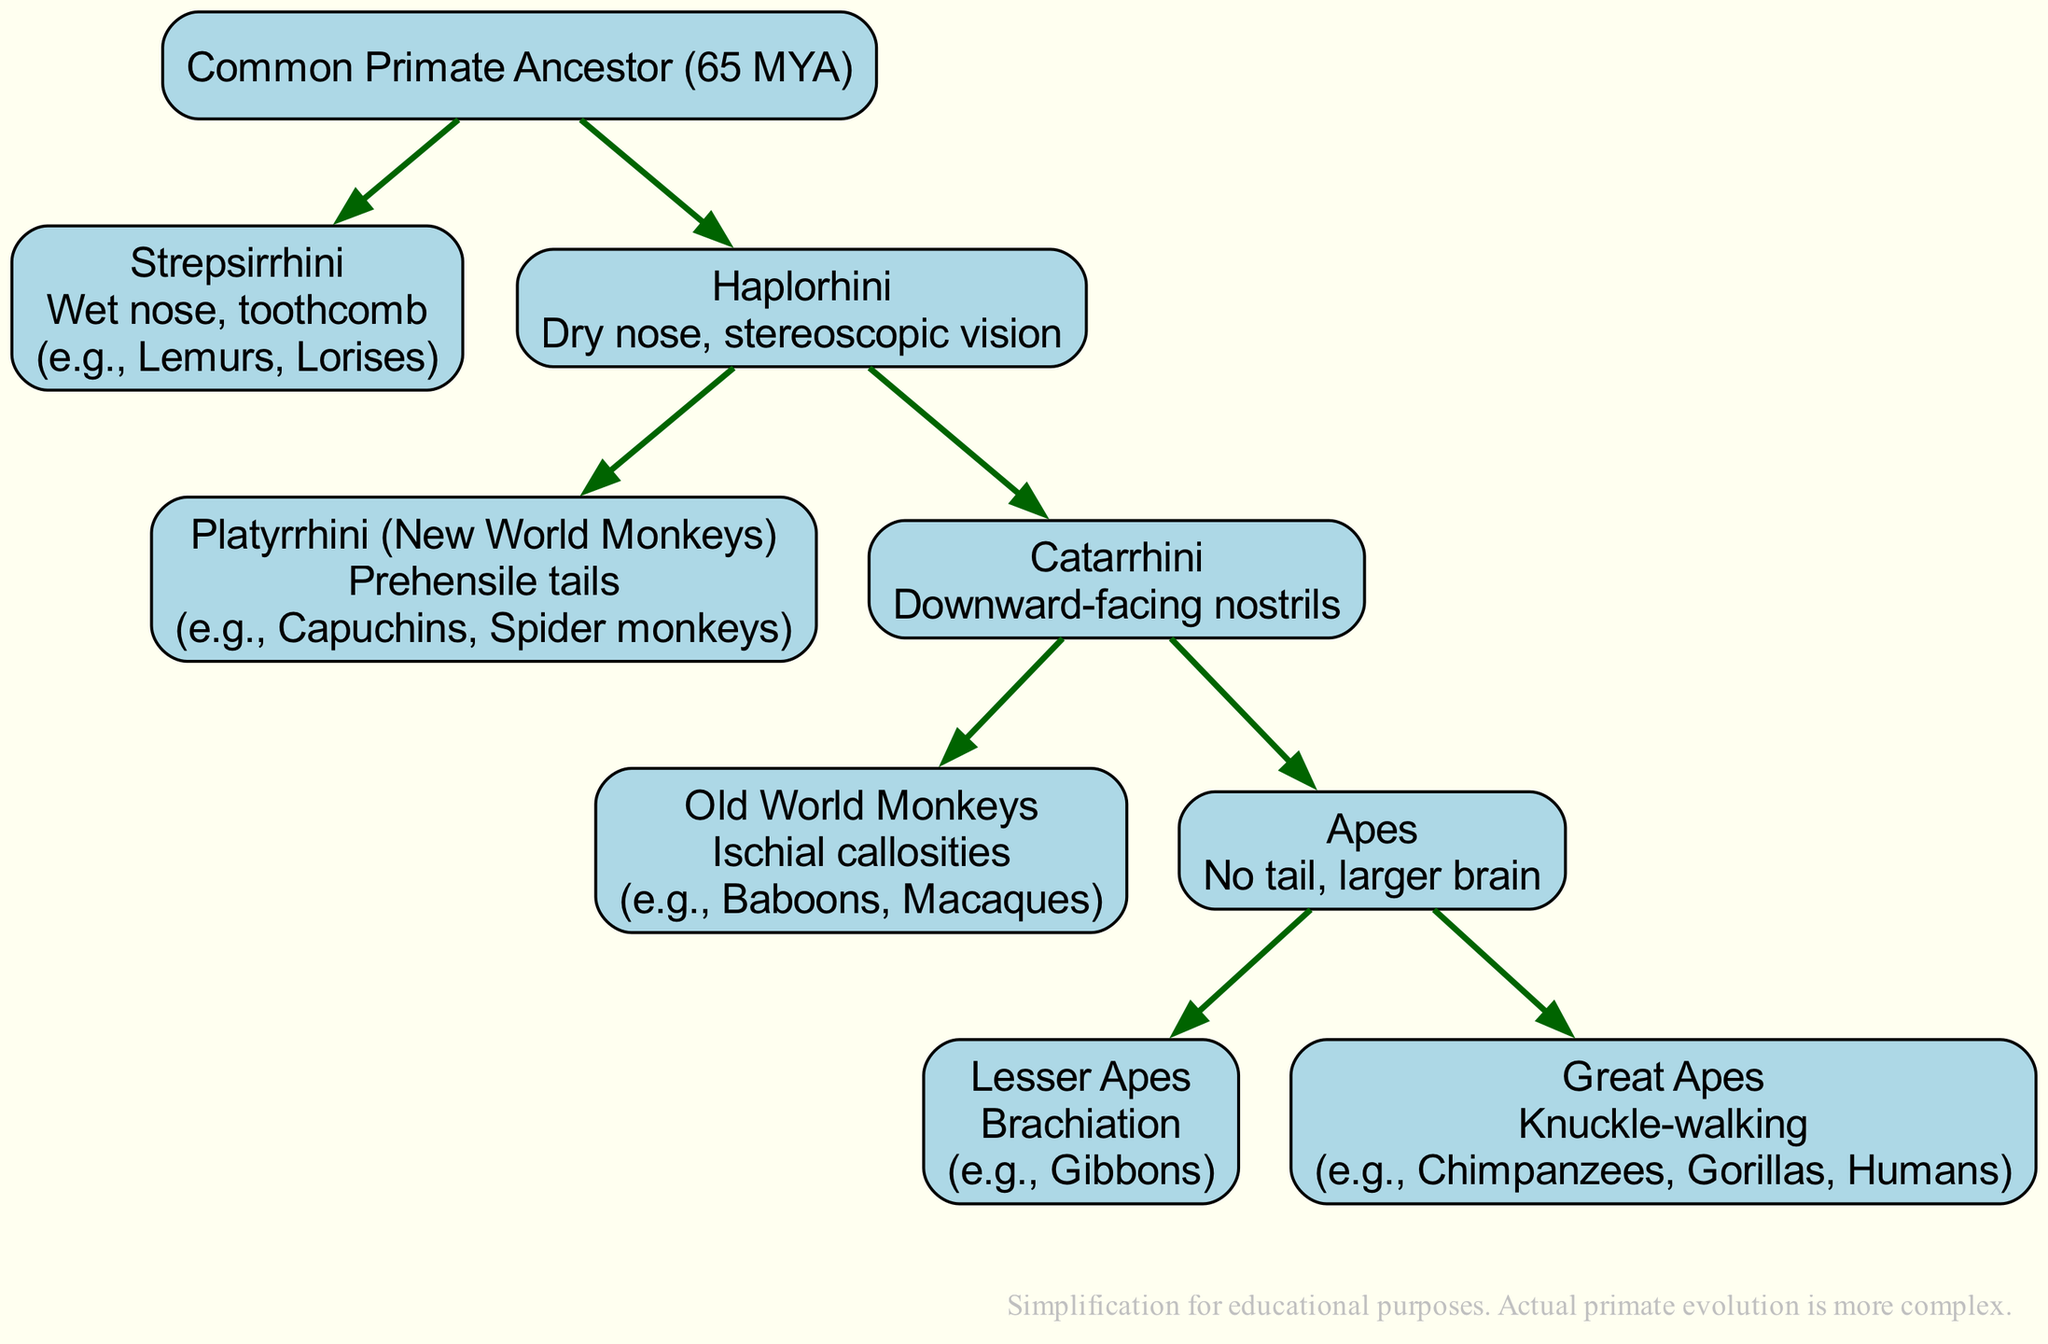What is the root of the evolutionary tree? The root of the evolutionary tree is labeled as the "Common Primate Ancestor (65 MYA)." This is the starting point from which all branches of primates diverge.
Answer: Common Primate Ancestor (65 MYA) How many main branches are there under Haplorhini? The Haplorhini branch has two main sub-branches: Platyrrhini and Catarrhini. These can be counted directly from the diagram after identifying them as the two branches that stem from Haplorhini.
Answer: 2 What adaptation is specific to Strepsirrhini? The adaptation associated with Strepsirrhini is "Wet nose, toothcomb." This information is directly stated in the corresponding box for the Strepsirrhini branch.
Answer: Wet nose, toothcomb Name an example of a New World Monkey. An example of a New World Monkey, which falls under the Platyrrhini branch, is “Capuchins.” This example is explicitly given in the branch details for Platyrrhini.
Answer: Capuchins What do Great Apes possess that distinguishes them from Lesser Apes? Great Apes are distinguished by "Knuckle-walking," which is mentioned in the description for the Great Apes branch, while Lesser Apes are described with "Brachiation." This highlights a significant behavioral adaptation that differentiates the two groups.
Answer: Knuckle-walking Which branch has adaptations of "Downward-facing nostrils"? The branch with the adaptations of "Downward-facing nostrils" is Catarrhini. This adaptation is stated in the node for Catarrhini along with the corresponding example branches.
Answer: Catarrhini How many examples are listed under Great Apes? There are three examples listed under Great Apes: Chimpanzees, Gorillas, and Humans. This count can be made by reviewing the examples provided in the Great Apes box.
Answer: 3 What unique adaptation do Old World Monkeys have? Old World Monkeys have "Ischial callosities" as a unique adaptation. This adaptation is clearly noted in the description of the Old World Monkeys branch.
Answer: Ischial callosities What is the most recent common ancestor represented in the diagram? The most recent common ancestor represented in the diagram is the "Common Primate Ancestor." This is identified as the root node from which all branches diverge and represents the earliest point in the evolutionary tree depicted.
Answer: Common Primate Ancestor 